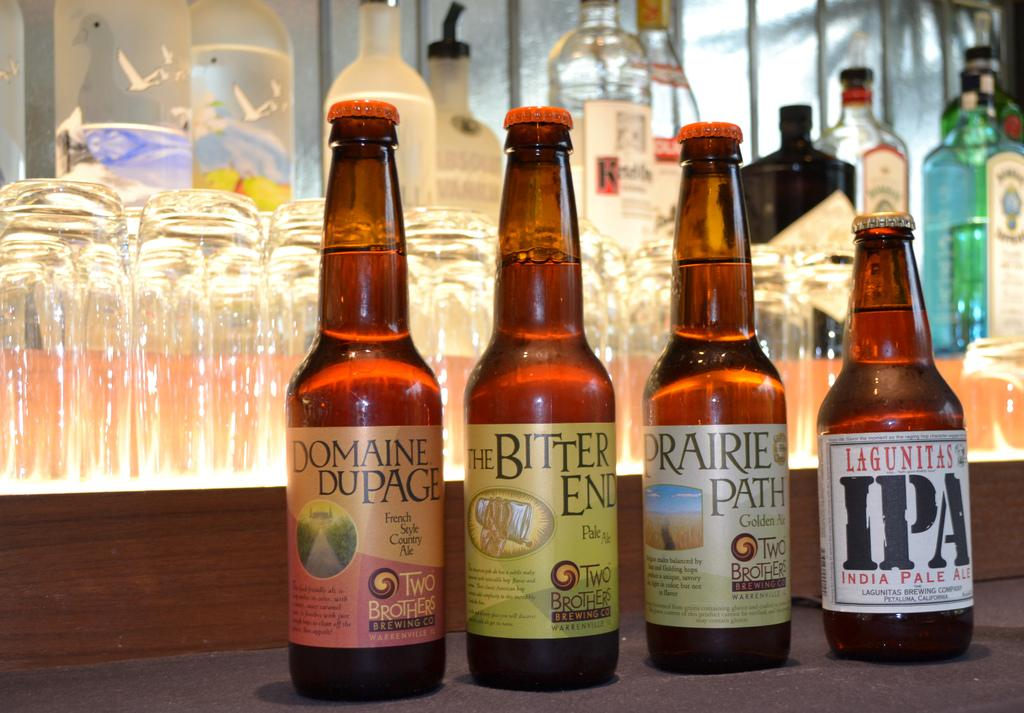<image>
Describe the image concisely. Four bottles of two brothers beer each of a different flavour sit on a counter. 